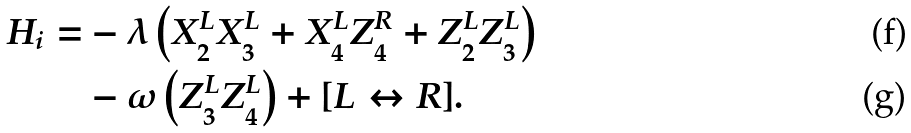<formula> <loc_0><loc_0><loc_500><loc_500>H _ { i } = & - \lambda \left ( X _ { 2 } ^ { L } X _ { 3 } ^ { L } + X _ { 4 } ^ { L } Z _ { 4 } ^ { R } + Z _ { 2 } ^ { L } Z _ { 3 } ^ { L } \right ) \\ & - \omega \left ( Z _ { 3 } ^ { L } Z _ { 4 } ^ { L } \right ) + [ L \leftrightarrow R ] .</formula> 